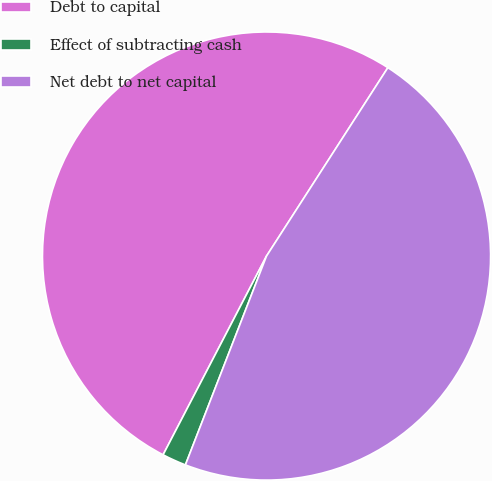Convert chart. <chart><loc_0><loc_0><loc_500><loc_500><pie_chart><fcel>Debt to capital<fcel>Effect of subtracting cash<fcel>Net debt to net capital<nl><fcel>51.47%<fcel>1.74%<fcel>46.79%<nl></chart> 